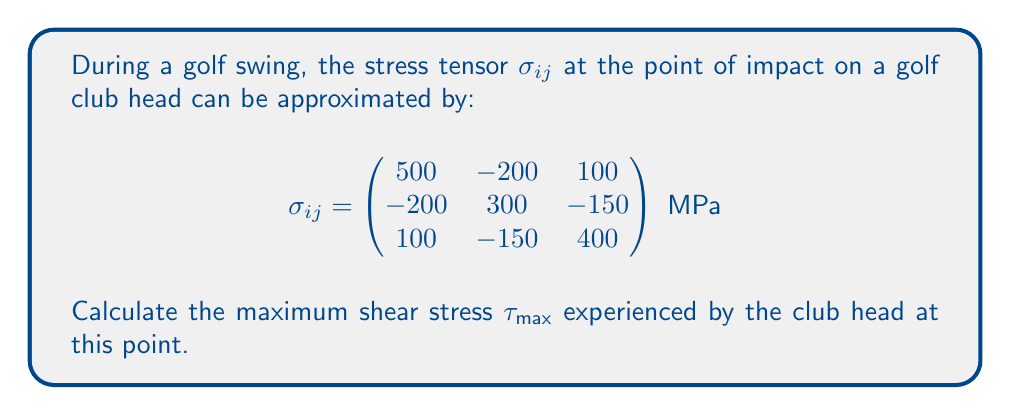Show me your answer to this math problem. To find the maximum shear stress, we'll follow these steps:

1) First, we need to calculate the principal stresses. These are the eigenvalues of the stress tensor.

2) The characteristic equation for the eigenvalues $\lambda$ is:
   $$\det(\sigma_{ij} - \lambda I) = 0$$

3) Expanding this determinant:
   $$\begin{vmatrix}
   500-\lambda & -200 & 100 \\
   -200 & 300-\lambda & -150 \\
   100 & -150 & 400-\lambda
   \end{vmatrix} = 0$$

4) This leads to the cubic equation:
   $$-\lambda^3 + 1200\lambda^2 - 385000\lambda + 32500000 = 0$$

5) Solving this equation (using a calculator or computer algebra system) gives the principal stresses:
   $$\lambda_1 \approx 676.4 \text{ MPa}$$
   $$\lambda_2 \approx 338.8 \text{ MPa}$$
   $$\lambda_3 \approx 184.8 \text{ MPa}$$

6) The maximum shear stress is given by:
   $$\tau_{\text{max}} = \frac{\lambda_1 - \lambda_3}{2}$$

7) Substituting the values:
   $$\tau_{\text{max}} = \frac{676.4 - 184.8}{2} = 245.8 \text{ MPa}$$
Answer: $\tau_{\text{max}} = 245.8 \text{ MPa}$ 